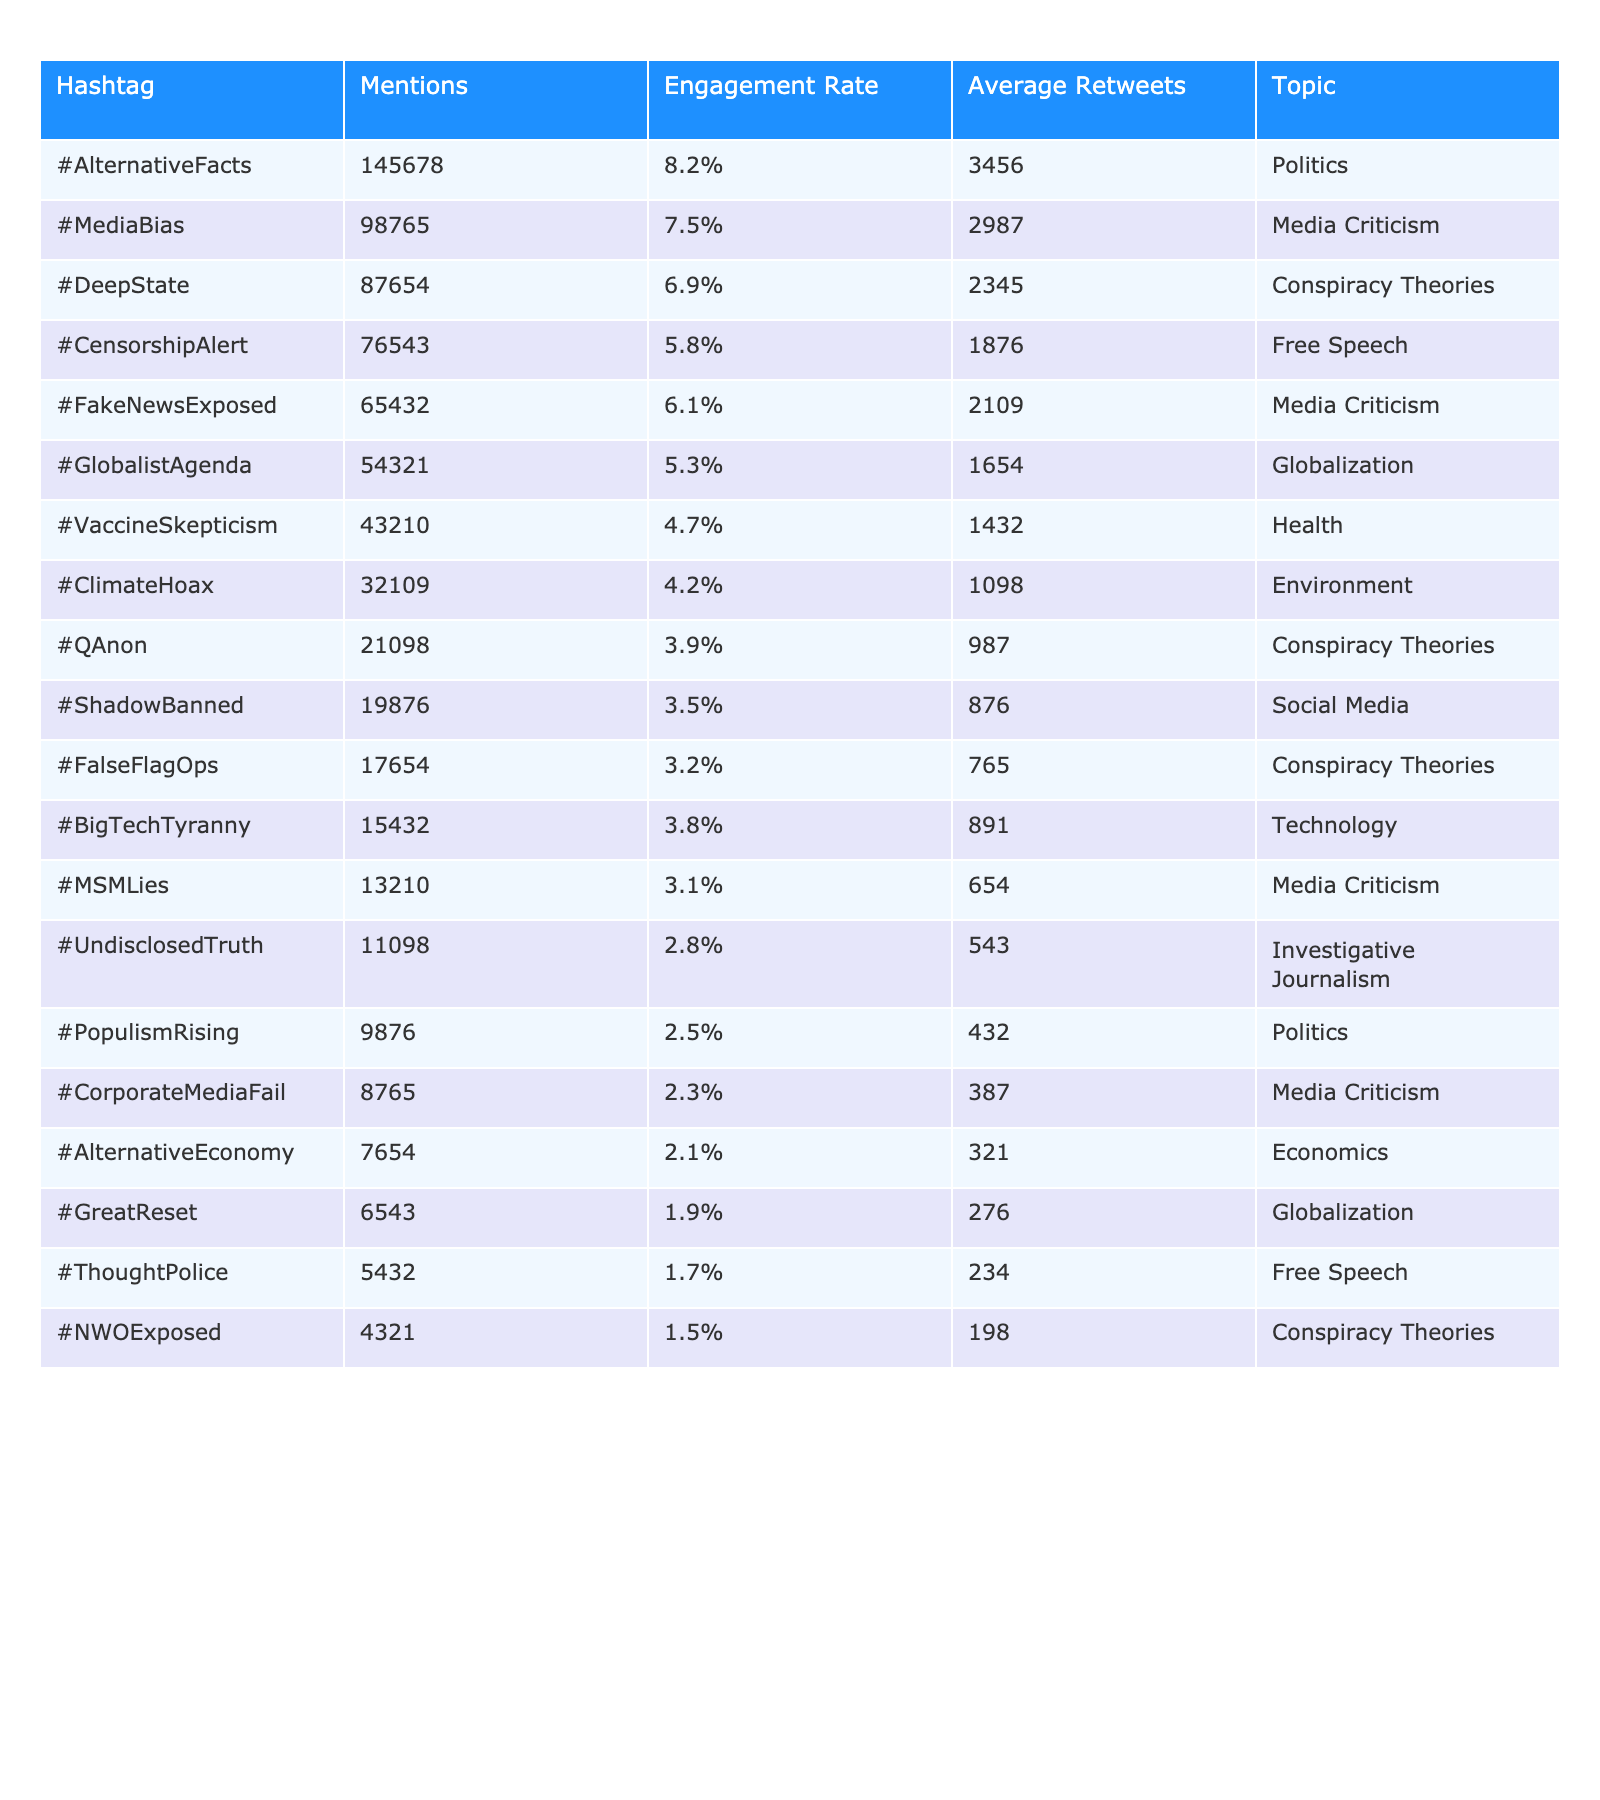What hashtag has the highest number of mentions? By reviewing the "Mentions" column in the table, we see that the hashtag with the highest number of mentions is #AlternativeFacts with 145678 mentions.
Answer: #AlternativeFacts What is the engagement rate of #FakeNewsExposed? The engagement rate for #FakeNewsExposed is provided in the table under the "Engagement Rate" column, which shows a rate of 6.1%.
Answer: 6.1% Which topic has the hashtag #DeepState associated with it? The table indicates that the topic associated with the hashtag #DeepState is "Conspiracy Theories".
Answer: Conspiracy Theories What is the average number of retweets for hashtags related to Media Criticism? The average number of retweets for the related hashtags (#MediaBias, #FakeNewsExposed, #MSMLies, #CorporateMediaFail) can be calculated by summing their retweets: (2987 + 2109 + 654 + 387) = 6137, and then dividing by 4 gives an average of 1534.25.
Answer: 1534.25 How many hashtags have an engagement rate higher than 5%? By counting the hashtags in the "Engagement Rate" column that are greater than 5%, we find that there are 4 such hashtags (#AlternativeFacts, #MediaBias, #FakeNewsExposed, #CensorshipAlert).
Answer: 4 Is the engagement rate of #CensorshipAlert higher than that of #VaccineSkepticism? By comparing the engagement rates listed in the table, #CensorshipAlert has an engagement rate of 5.8%, while #VaccineSkepticism has a rate of 4.7%. Therefore, #CensorshipAlert's rate is indeed higher.
Answer: Yes Which hashtag related to Health has the lowest engagement rate? In the table, the only hashtag related to Health is #VaccineSkepticism, which has an engagement rate of 4.7%. Since it's the only one, it is also the lowest.
Answer: #VaccineSkepticism What is the difference in average retweets between #QAnon and #ClimateHoax? To find the difference, we subtract the average retweets of #ClimateHoax (1098) from that of #QAnon (987). Thus, 987 - 1098 = -111. The average retweets for #QAnon are less when compared to #ClimateHoax.
Answer: -111 Count how many hashtags in the table are explicitly about Politics. By checking the "Topic" column for mentions of "Politics", we see that there are two hashtags listed (#AlternativeFacts and #PopulismRising).
Answer: 2 Which three topics have the most hashtags associated with them? We can tally the number of occurrences for each topic by reviewing the table: Media Criticism (4), Conspiracy Theories (4), and Politics (2). Therefore, the top three topics tied in frequency are Media Criticism and Conspiracy Theories, each with 4 hashtags.
Answer: Media Criticism, Conspiracy Theories What is the total number of mentions for hashtags related to Globalization? The total mentions for the hashtags #GlobalistAgenda and #GreatReset yield us a sum of 54321 + 6543 = 60864 mentions.
Answer: 60864 